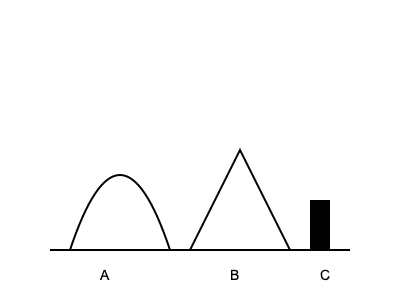In the illustration above, three traditional Polish farming tools are depicted. Which of these tools, labeled A, B, and C, represents the "kosa" (scythe) used for harvesting crops in medieval Poland? To identify the "kosa" (scythe) among the illustrated tools, let's analyze each one:

1. Tool A: This curved implement with a long handle represents the "kosa" (scythe). The scythe was a crucial tool in medieval Polish agriculture, used for cutting grass or harvesting crops. Its distinctive curved blade and long handle allowed farmers to work efficiently in large fields.

2. Tool B: This angular tool resembles a "sierp" (sickle). While also used for harvesting, the sickle is smaller and has a more pronounced curve than the scythe. It was typically used for smaller-scale harvesting or in areas where a scythe might be impractical.

3. Tool C: This rectangular shape likely represents a "motyka" (hoe). Hoes were used for tilling soil, removing weeds, and creating furrows for planting. Unlike the scythe and sickle, it was not primarily a harvesting tool.

Given the question asks specifically about the "kosa" (scythe), the correct answer is Tool A. Its long, gently curved shape is characteristic of the scythes used in medieval Polish agriculture for efficient harvesting of crops in large fields.
Answer: A 